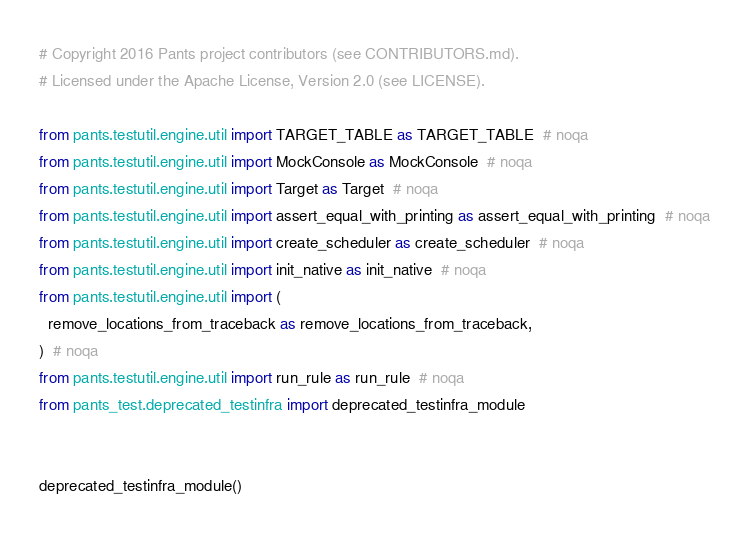Convert code to text. <code><loc_0><loc_0><loc_500><loc_500><_Python_># Copyright 2016 Pants project contributors (see CONTRIBUTORS.md).
# Licensed under the Apache License, Version 2.0 (see LICENSE).

from pants.testutil.engine.util import TARGET_TABLE as TARGET_TABLE  # noqa
from pants.testutil.engine.util import MockConsole as MockConsole  # noqa
from pants.testutil.engine.util import Target as Target  # noqa
from pants.testutil.engine.util import assert_equal_with_printing as assert_equal_with_printing  # noqa
from pants.testutil.engine.util import create_scheduler as create_scheduler  # noqa
from pants.testutil.engine.util import init_native as init_native  # noqa
from pants.testutil.engine.util import (
  remove_locations_from_traceback as remove_locations_from_traceback,
)  # noqa
from pants.testutil.engine.util import run_rule as run_rule  # noqa
from pants_test.deprecated_testinfra import deprecated_testinfra_module


deprecated_testinfra_module()
</code> 